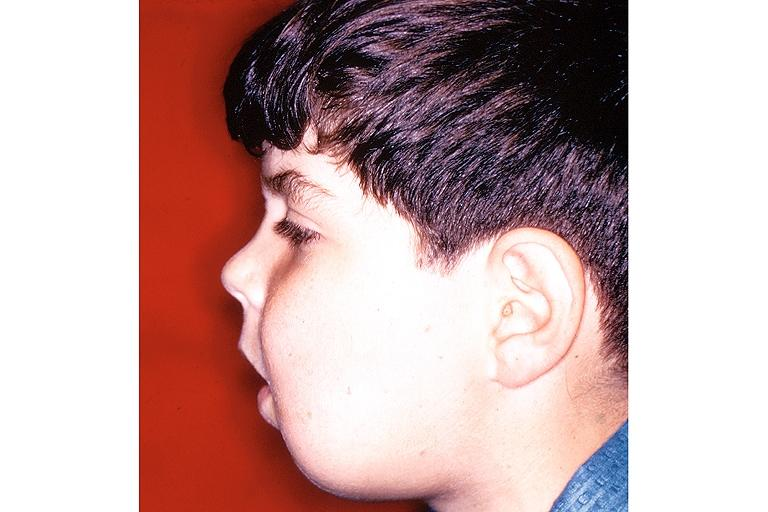where is this?
Answer the question using a single word or phrase. Oral 